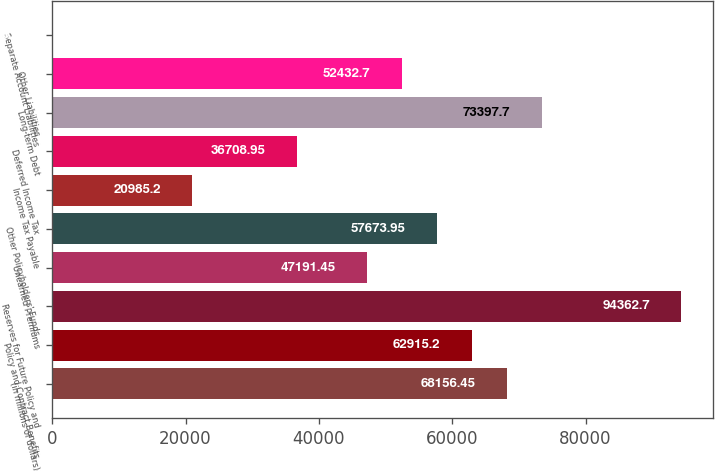<chart> <loc_0><loc_0><loc_500><loc_500><bar_chart><fcel>(in millions of dollars)<fcel>Policy and Contract Benefits<fcel>Reserves for Future Policy and<fcel>Unearned Premiums<fcel>Other Policyholders' Funds<fcel>Income Tax Payable<fcel>Deferred Income Tax<fcel>Long-term Debt<fcel>Other Liabilities<fcel>Separate Account Liabilities<nl><fcel>68156.4<fcel>62915.2<fcel>94362.7<fcel>47191.4<fcel>57673.9<fcel>20985.2<fcel>36708.9<fcel>73397.7<fcel>52432.7<fcel>20.2<nl></chart> 